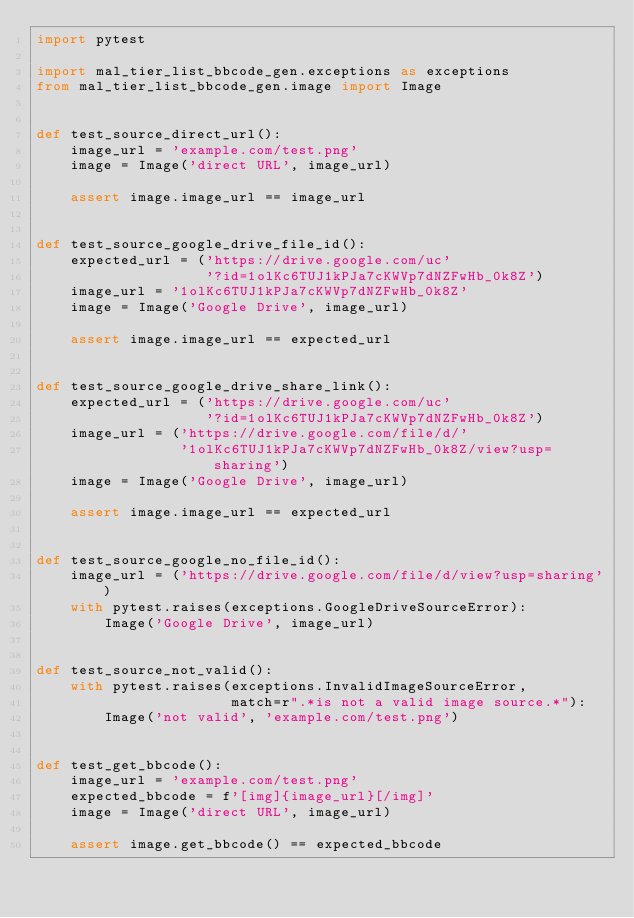<code> <loc_0><loc_0><loc_500><loc_500><_Python_>import pytest

import mal_tier_list_bbcode_gen.exceptions as exceptions
from mal_tier_list_bbcode_gen.image import Image


def test_source_direct_url():
    image_url = 'example.com/test.png'
    image = Image('direct URL', image_url)

    assert image.image_url == image_url


def test_source_google_drive_file_id():
    expected_url = ('https://drive.google.com/uc'
                    '?id=1olKc6TUJ1kPJa7cKWVp7dNZFwHb_0k8Z')
    image_url = '1olKc6TUJ1kPJa7cKWVp7dNZFwHb_0k8Z'
    image = Image('Google Drive', image_url)

    assert image.image_url == expected_url


def test_source_google_drive_share_link():
    expected_url = ('https://drive.google.com/uc'
                    '?id=1olKc6TUJ1kPJa7cKWVp7dNZFwHb_0k8Z')
    image_url = ('https://drive.google.com/file/d/'
                 '1olKc6TUJ1kPJa7cKWVp7dNZFwHb_0k8Z/view?usp=sharing')
    image = Image('Google Drive', image_url)

    assert image.image_url == expected_url


def test_source_google_no_file_id():
    image_url = ('https://drive.google.com/file/d/view?usp=sharing')
    with pytest.raises(exceptions.GoogleDriveSourceError):
        Image('Google Drive', image_url)


def test_source_not_valid():
    with pytest.raises(exceptions.InvalidImageSourceError,
                       match=r".*is not a valid image source.*"):
        Image('not valid', 'example.com/test.png')


def test_get_bbcode():
    image_url = 'example.com/test.png'
    expected_bbcode = f'[img]{image_url}[/img]'
    image = Image('direct URL', image_url)

    assert image.get_bbcode() == expected_bbcode
</code> 